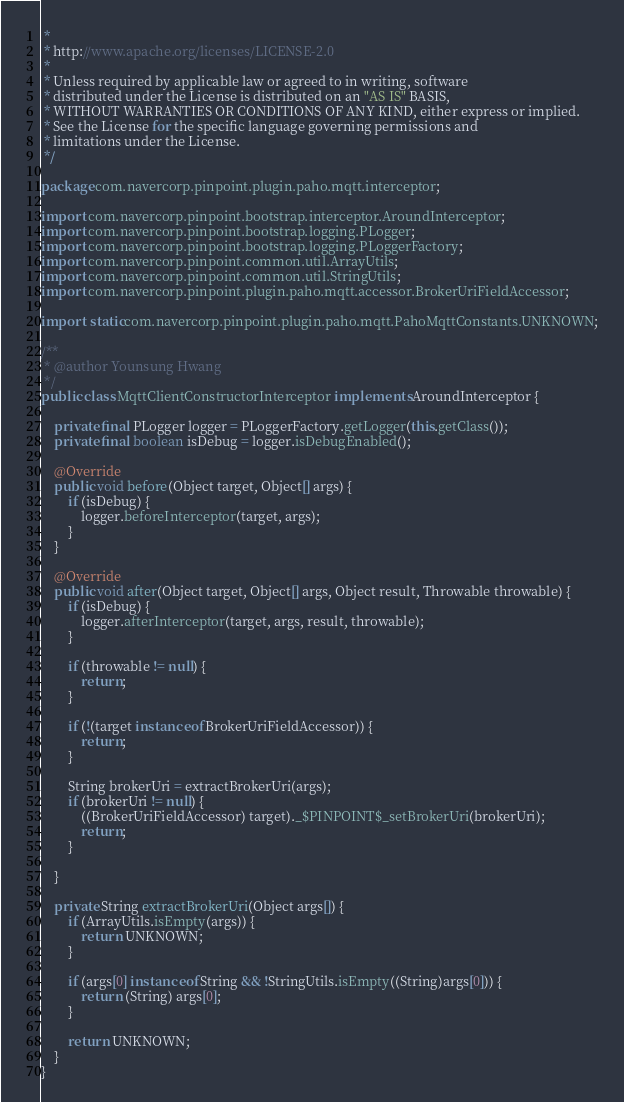Convert code to text. <code><loc_0><loc_0><loc_500><loc_500><_Java_> *
 * http://www.apache.org/licenses/LICENSE-2.0
 *
 * Unless required by applicable law or agreed to in writing, software
 * distributed under the License is distributed on an "AS IS" BASIS,
 * WITHOUT WARRANTIES OR CONDITIONS OF ANY KIND, either express or implied.
 * See the License for the specific language governing permissions and
 * limitations under the License.
 */

package com.navercorp.pinpoint.plugin.paho.mqtt.interceptor;

import com.navercorp.pinpoint.bootstrap.interceptor.AroundInterceptor;
import com.navercorp.pinpoint.bootstrap.logging.PLogger;
import com.navercorp.pinpoint.bootstrap.logging.PLoggerFactory;
import com.navercorp.pinpoint.common.util.ArrayUtils;
import com.navercorp.pinpoint.common.util.StringUtils;
import com.navercorp.pinpoint.plugin.paho.mqtt.accessor.BrokerUriFieldAccessor;

import static com.navercorp.pinpoint.plugin.paho.mqtt.PahoMqttConstants.UNKNOWN;

/**
 * @author Younsung Hwang
 */
public class MqttClientConstructorInterceptor implements AroundInterceptor {

    private final PLogger logger = PLoggerFactory.getLogger(this.getClass());
    private final boolean isDebug = logger.isDebugEnabled();

    @Override
    public void before(Object target, Object[] args) {
        if (isDebug) {
            logger.beforeInterceptor(target, args);
        }
    }

    @Override
    public void after(Object target, Object[] args, Object result, Throwable throwable) {
        if (isDebug) {
            logger.afterInterceptor(target, args, result, throwable);
        }

        if (throwable != null) {
            return;
        }

        if (!(target instanceof BrokerUriFieldAccessor)) {
            return;
        }

        String brokerUri = extractBrokerUri(args);
        if (brokerUri != null) {
            ((BrokerUriFieldAccessor) target)._$PINPOINT$_setBrokerUri(brokerUri);
            return;
        }

    }

    private String extractBrokerUri(Object args[]) {
        if (ArrayUtils.isEmpty(args)) {
            return UNKNOWN;
        }

        if (args[0] instanceof String && !StringUtils.isEmpty((String)args[0])) {
            return (String) args[0];
        }

        return UNKNOWN;
    }
}
</code> 